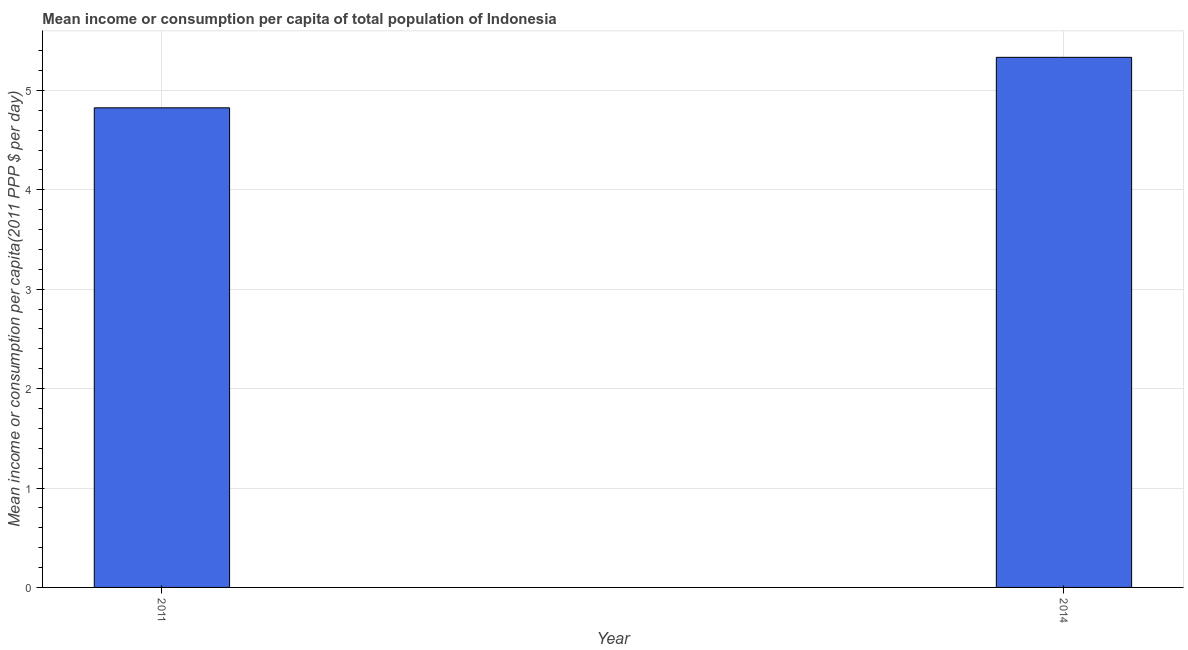Does the graph contain any zero values?
Your answer should be compact. No. What is the title of the graph?
Your answer should be very brief. Mean income or consumption per capita of total population of Indonesia. What is the label or title of the Y-axis?
Give a very brief answer. Mean income or consumption per capita(2011 PPP $ per day). What is the mean income or consumption in 2011?
Make the answer very short. 4.82. Across all years, what is the maximum mean income or consumption?
Keep it short and to the point. 5.33. Across all years, what is the minimum mean income or consumption?
Your answer should be compact. 4.82. What is the sum of the mean income or consumption?
Your response must be concise. 10.16. What is the difference between the mean income or consumption in 2011 and 2014?
Offer a very short reply. -0.51. What is the average mean income or consumption per year?
Provide a short and direct response. 5.08. What is the median mean income or consumption?
Provide a short and direct response. 5.08. Do a majority of the years between 2014 and 2011 (inclusive) have mean income or consumption greater than 2.6 $?
Provide a succinct answer. No. What is the ratio of the mean income or consumption in 2011 to that in 2014?
Your answer should be compact. 0.91. Is the mean income or consumption in 2011 less than that in 2014?
Your response must be concise. Yes. In how many years, is the mean income or consumption greater than the average mean income or consumption taken over all years?
Keep it short and to the point. 1. Are all the bars in the graph horizontal?
Keep it short and to the point. No. How many years are there in the graph?
Your response must be concise. 2. Are the values on the major ticks of Y-axis written in scientific E-notation?
Your answer should be very brief. No. What is the Mean income or consumption per capita(2011 PPP $ per day) in 2011?
Make the answer very short. 4.82. What is the Mean income or consumption per capita(2011 PPP $ per day) of 2014?
Give a very brief answer. 5.33. What is the difference between the Mean income or consumption per capita(2011 PPP $ per day) in 2011 and 2014?
Your answer should be compact. -0.51. What is the ratio of the Mean income or consumption per capita(2011 PPP $ per day) in 2011 to that in 2014?
Your answer should be compact. 0.91. 